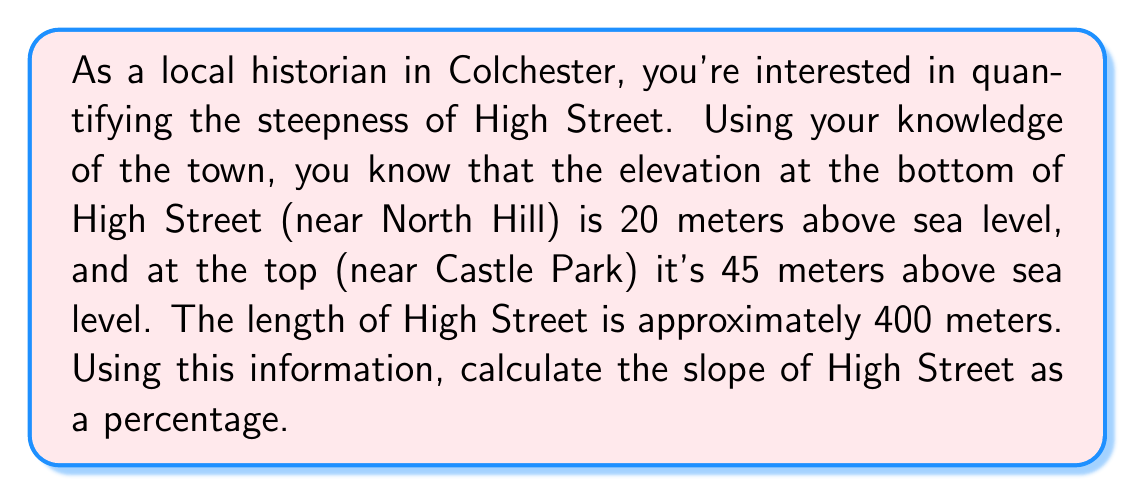Provide a solution to this math problem. To find the slope of High Street, we can use the linear equation for slope:

$$ m = \frac{\text{rise}}{\text{run}} = \frac{\text{change in y}}{\text{change in x}} $$

Let's define our variables:
$y_1 = 20$ meters (elevation at the bottom)
$y_2 = 45$ meters (elevation at the top)
$x_1 = 0$ meters (starting point)
$x_2 = 400$ meters (ending point)

Now, let's calculate the slope:

$$ m = \frac{y_2 - y_1}{x_2 - x_1} = \frac{45 - 20}{400 - 0} = \frac{25}{400} = 0.0625 $$

This gives us the slope as a decimal. To convert it to a percentage, we multiply by 100:

$$ \text{Slope as percentage} = 0.0625 \times 100 = 6.25\% $$

Therefore, the slope of High Street in Colchester is 6.25%.
Answer: The slope of High Street in Colchester is 6.25%. 